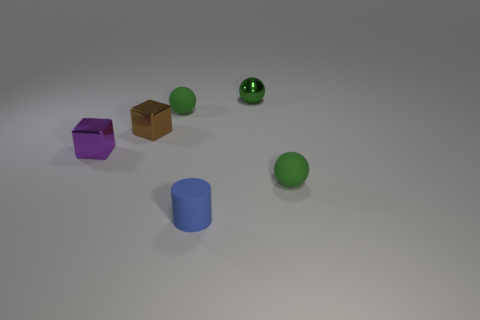Subtract all green balls. How many were subtracted if there are1green balls left? 2 Subtract all tiny green matte spheres. How many spheres are left? 1 Add 2 large brown metallic blocks. How many objects exist? 8 Subtract all brown cubes. How many cubes are left? 1 Subtract all cylinders. How many objects are left? 5 Subtract all small matte cylinders. Subtract all green metal objects. How many objects are left? 4 Add 5 shiny spheres. How many shiny spheres are left? 6 Add 3 tiny green rubber things. How many tiny green rubber things exist? 5 Subtract 1 purple blocks. How many objects are left? 5 Subtract all yellow cubes. Subtract all brown cylinders. How many cubes are left? 2 